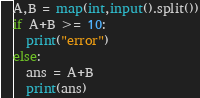<code> <loc_0><loc_0><loc_500><loc_500><_Python_>A,B = map(int,input().split())
if A+B >= 10:
  print("error")
else:
  ans = A+B
  print(ans)</code> 